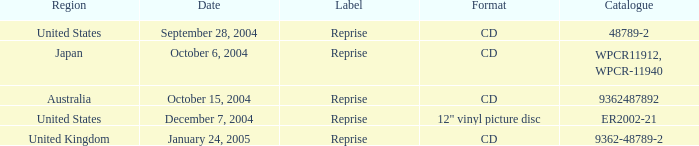Could you help me parse every detail presented in this table? {'header': ['Region', 'Date', 'Label', 'Format', 'Catalogue'], 'rows': [['United States', 'September 28, 2004', 'Reprise', 'CD', '48789-2'], ['Japan', 'October 6, 2004', 'Reprise', 'CD', 'WPCR11912, WPCR-11940'], ['Australia', 'October 15, 2004', 'Reprise', 'CD', '9362487892'], ['United States', 'December 7, 2004', 'Reprise', '12" vinyl picture disc', 'ER2002-21'], ['United Kingdom', 'January 24, 2005', 'Reprise', 'CD', '9362-48789-2']]} Name the catalogue for australia 9362487892.0. 